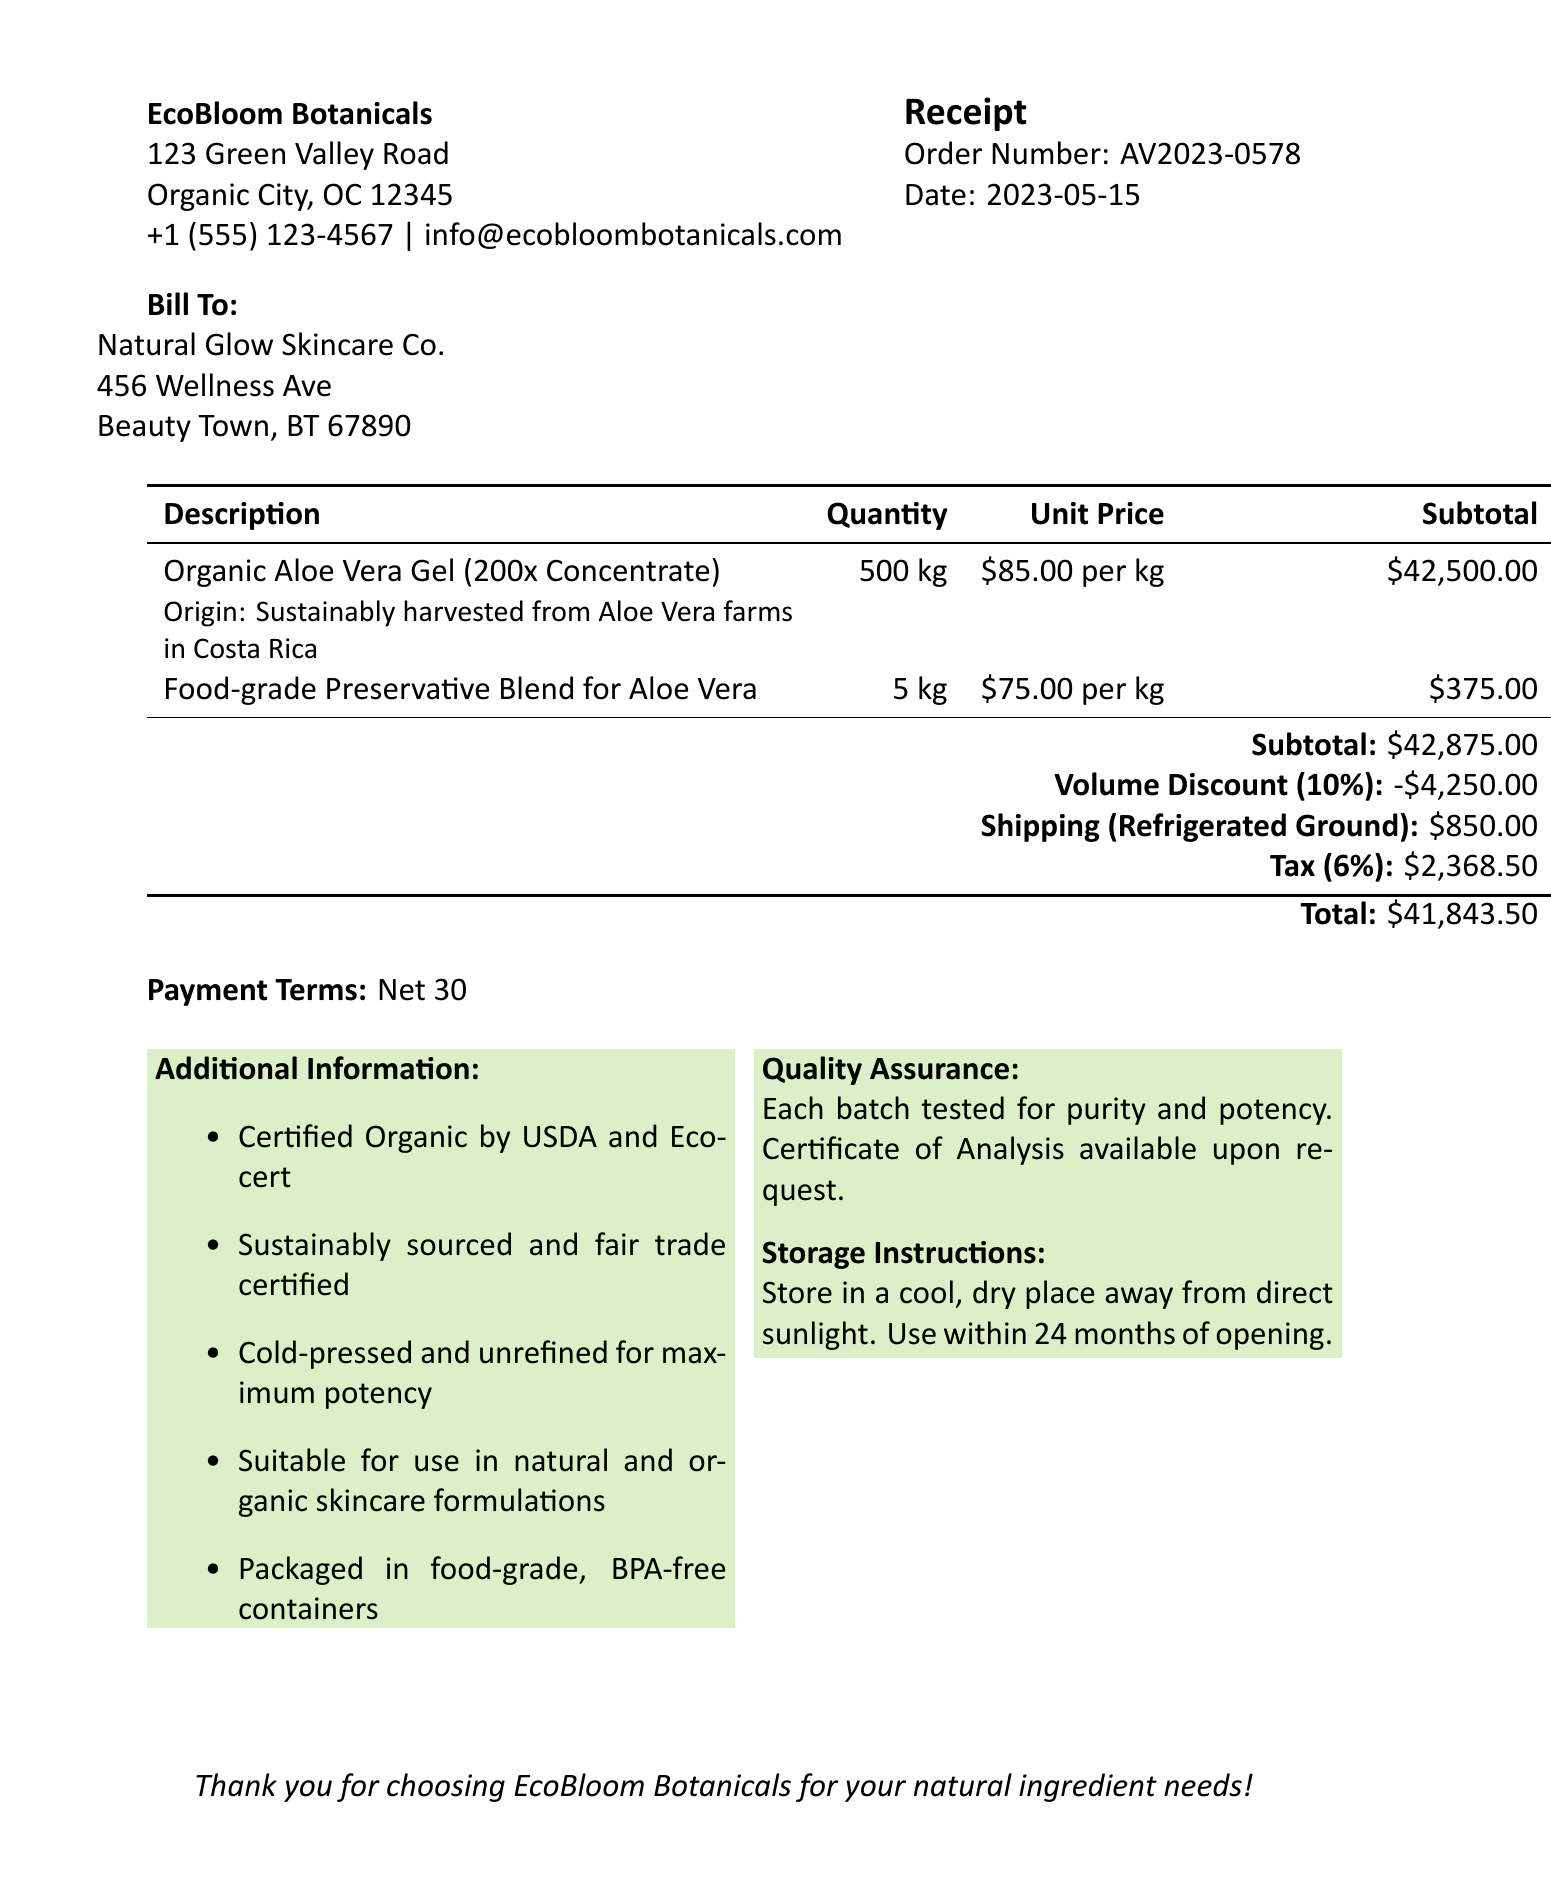What is the order number? The order number is clearly stated in the document for reference purposes.
Answer: AV2023-0578 Who is the customer? The customer information is provided under the billing section of the receipt.
Answer: Natural Glow Skincare Co What is the total amount due? The total amount due is calculated at the bottom of the receipt.
Answer: $41,843.50 What discount was applied to the order? The volume discount applied is specified in the document, detailing the percentage and amount.
Answer: 10% discount on orders over 400 kg How much is the shipping cost? The cost of shipping is explicitly mentioned in the shipping section.
Answer: $850.00 What is the quantity of Organic Aloe Vera Gel ordered? The quantity of the main item is indicated in the itemized list.
Answer: 500 kg What is the tax rate applied to this order? The tax rate can be found as part of the calculations on the receipt.
Answer: 6% What is the payment term for this order? The payment terms are stated clearly in the document to inform the customer of the due period.
Answer: Net 30 What are the storage instructions provided? The receipt contains specific storage instructions listed for customer reference.
Answer: Store in a cool, dry place away from direct sunlight. Use within 24 months of opening 